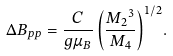<formula> <loc_0><loc_0><loc_500><loc_500>\Delta B _ { p p } = { \frac { C } { g \mu _ { B } } \left ( \frac { { M _ { 2 } } ^ { 3 } } { M _ { 4 } } \right ) } ^ { 1 / 2 } .</formula> 